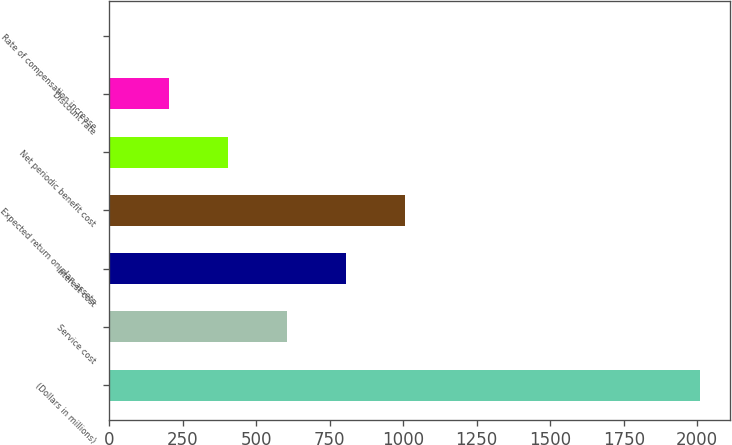Convert chart to OTSL. <chart><loc_0><loc_0><loc_500><loc_500><bar_chart><fcel>(Dollars in millions)<fcel>Service cost<fcel>Interest cost<fcel>Expected return on plan assets<fcel>Net periodic benefit cost<fcel>Discount rate<fcel>Rate of compensation increase<nl><fcel>2010<fcel>606.26<fcel>806.79<fcel>1007.32<fcel>405.73<fcel>205.2<fcel>4.67<nl></chart> 